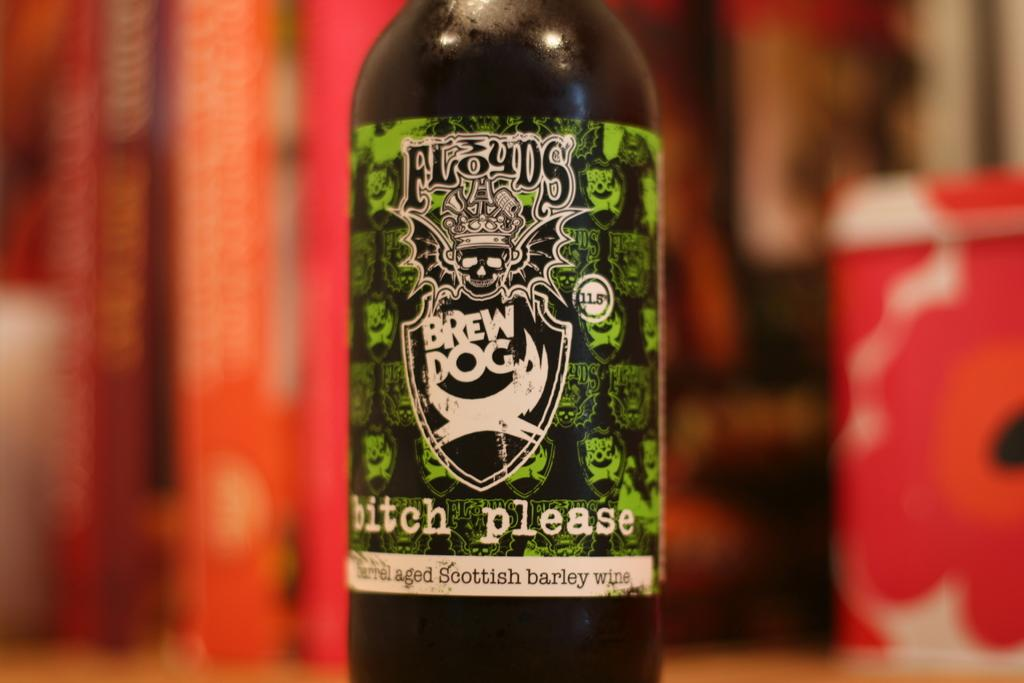Provide a one-sentence caption for the provided image. Close up of a Brew Dog bitch please beer bottle sitting on a table. 